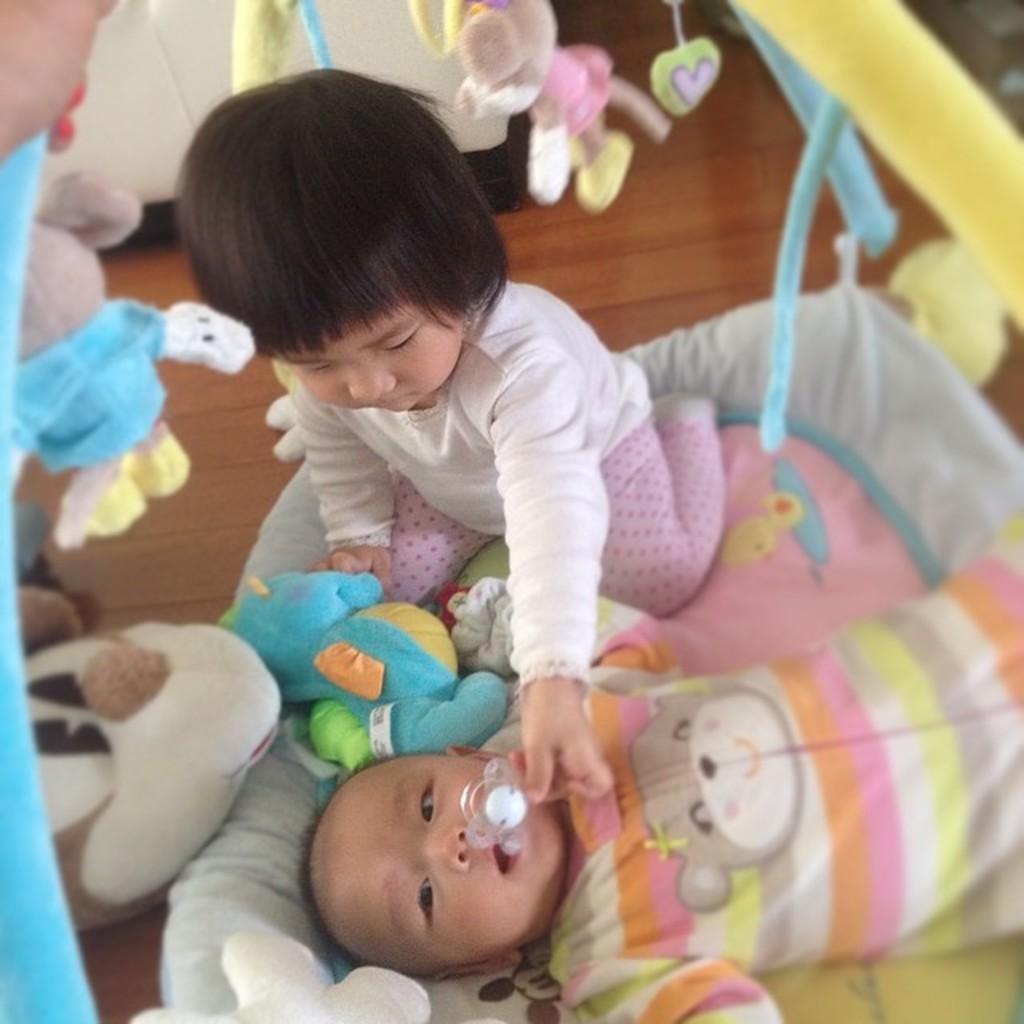In one or two sentences, can you explain what this image depicts? In the foreground of this picture, there is a girl and a baby on a bed and we can also see toys hanging to the bed. In the background, we can see floor and the cupboard. 